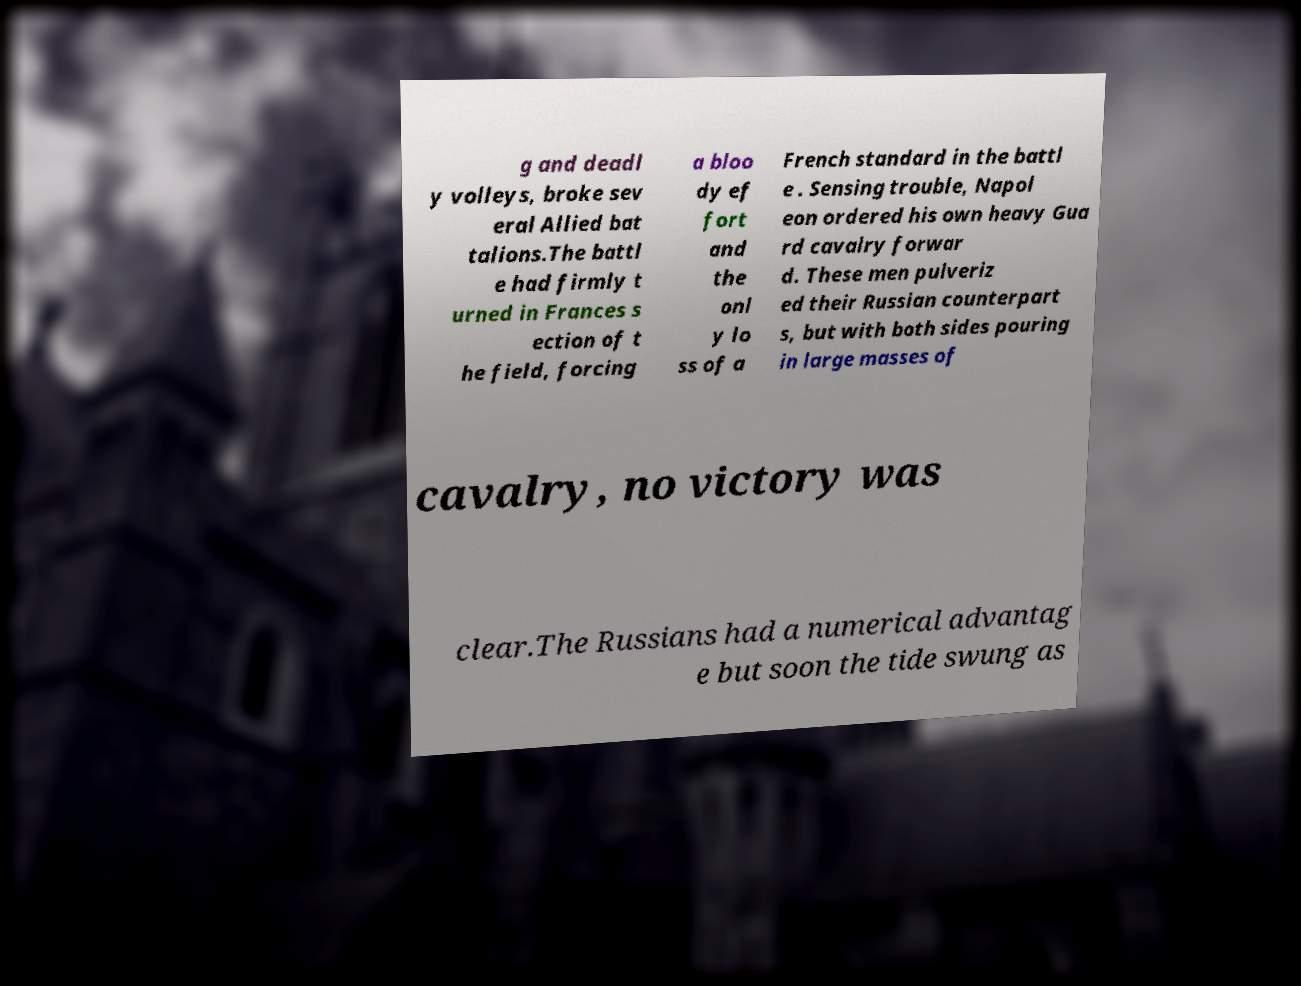I need the written content from this picture converted into text. Can you do that? g and deadl y volleys, broke sev eral Allied bat talions.The battl e had firmly t urned in Frances s ection of t he field, forcing a bloo dy ef fort and the onl y lo ss of a French standard in the battl e . Sensing trouble, Napol eon ordered his own heavy Gua rd cavalry forwar d. These men pulveriz ed their Russian counterpart s, but with both sides pouring in large masses of cavalry, no victory was clear.The Russians had a numerical advantag e but soon the tide swung as 